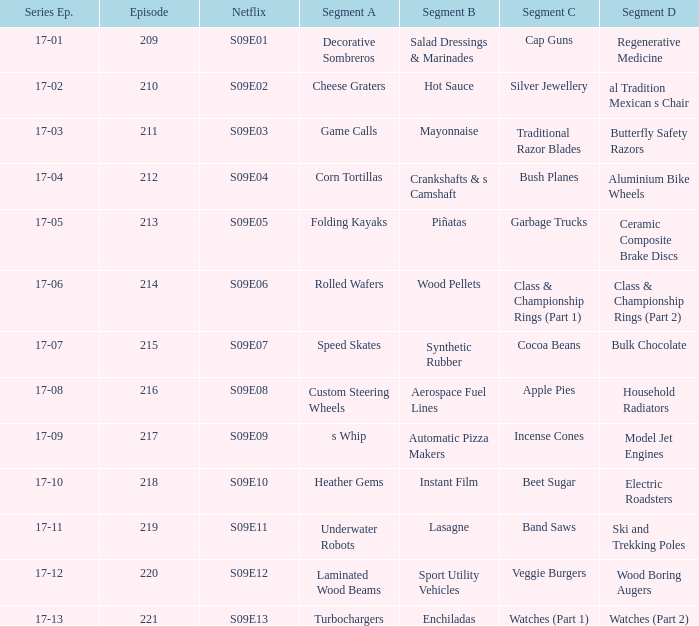In which netflix episode can segment a of heather gems be found? S09E10. 